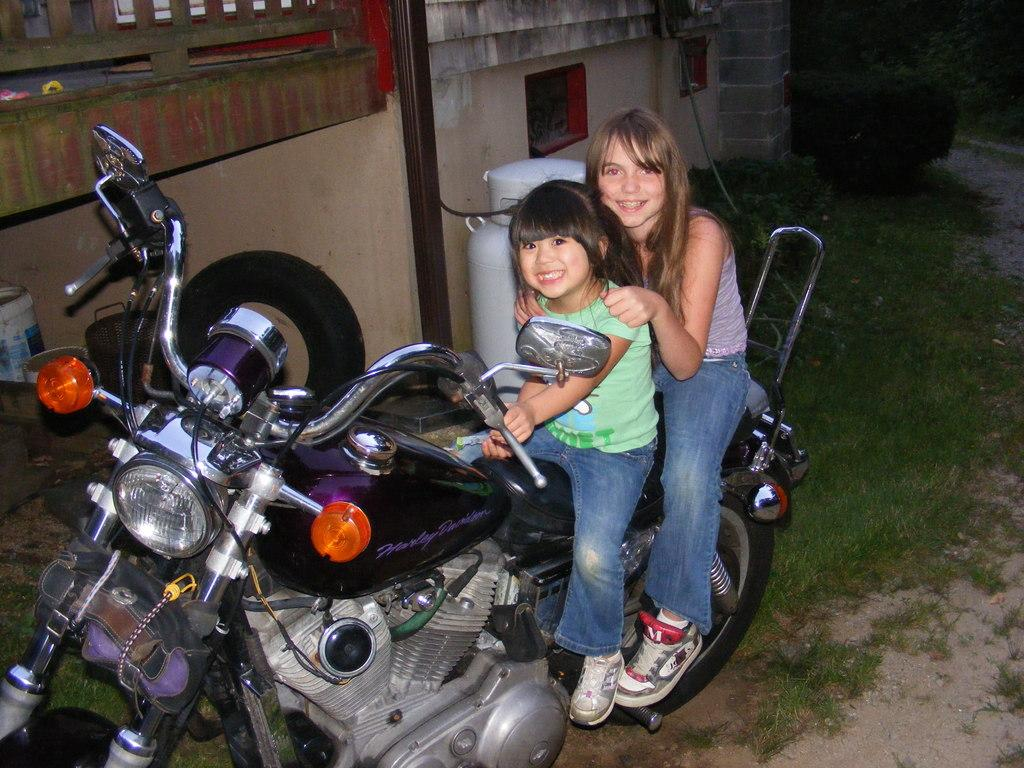What is the main object in the image? There is a bike in the image. Who is on the bike? Two girls are sitting on the bike. What is the surface beneath the bike? The floor is made of grass. What can be seen on the left side of the image? There is a wall on the left side of the image. What type of animal is the girls' love limit in the image? There is no animal or love limit mentioned in the image; it features a bike with two girls sitting on it, a grassy floor, and a wall on the left side. 